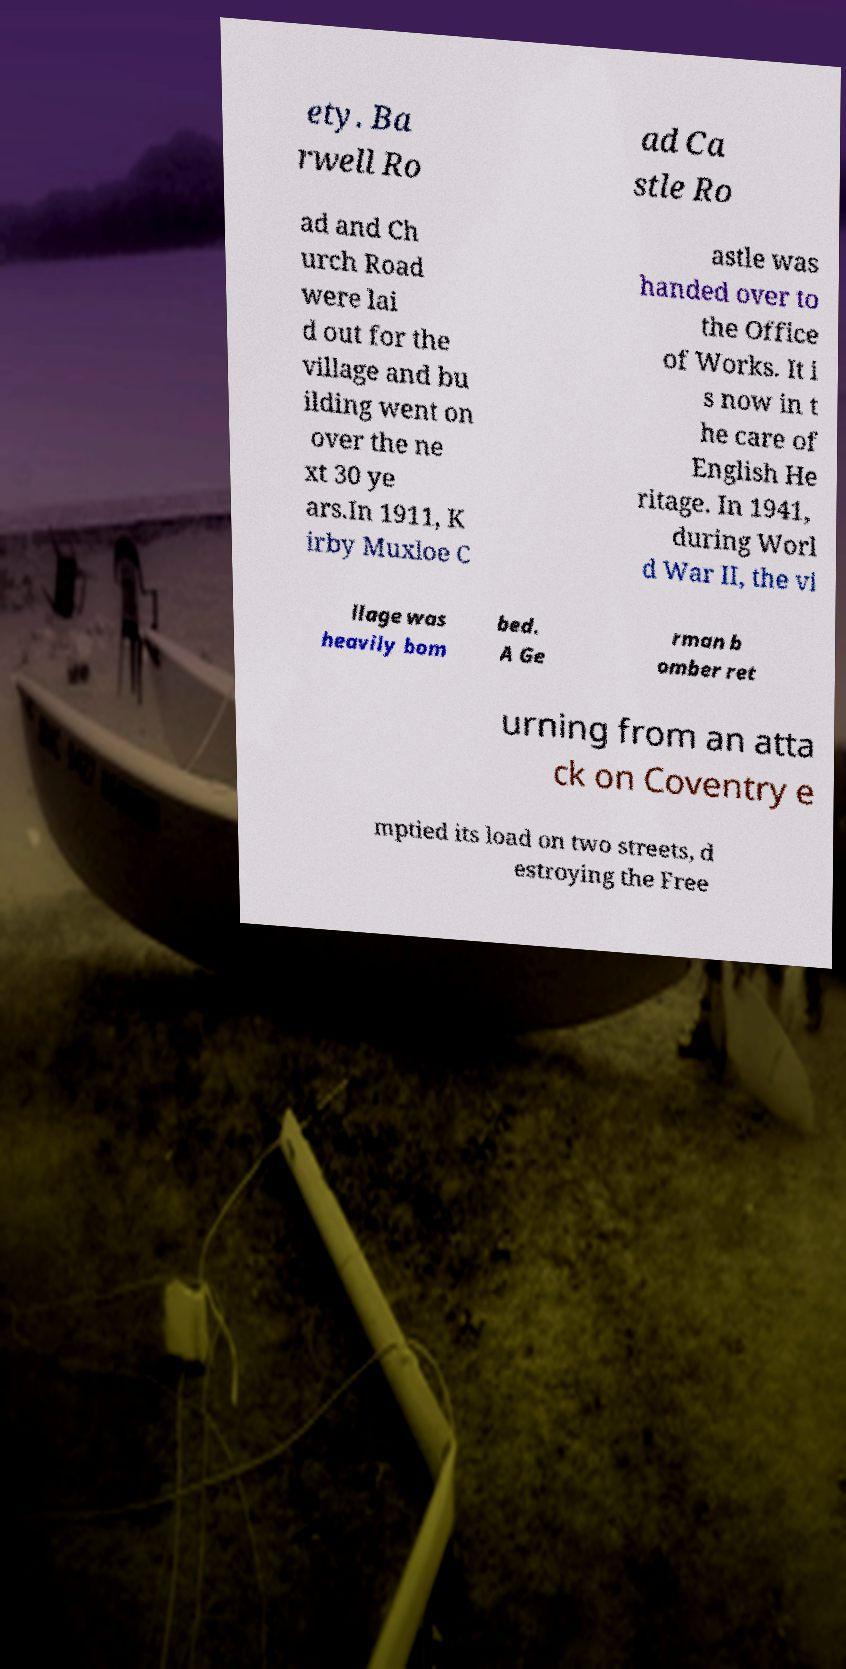Can you accurately transcribe the text from the provided image for me? ety. Ba rwell Ro ad Ca stle Ro ad and Ch urch Road were lai d out for the village and bu ilding went on over the ne xt 30 ye ars.In 1911, K irby Muxloe C astle was handed over to the Office of Works. It i s now in t he care of English He ritage. In 1941, during Worl d War II, the vi llage was heavily bom bed. A Ge rman b omber ret urning from an atta ck on Coventry e mptied its load on two streets, d estroying the Free 